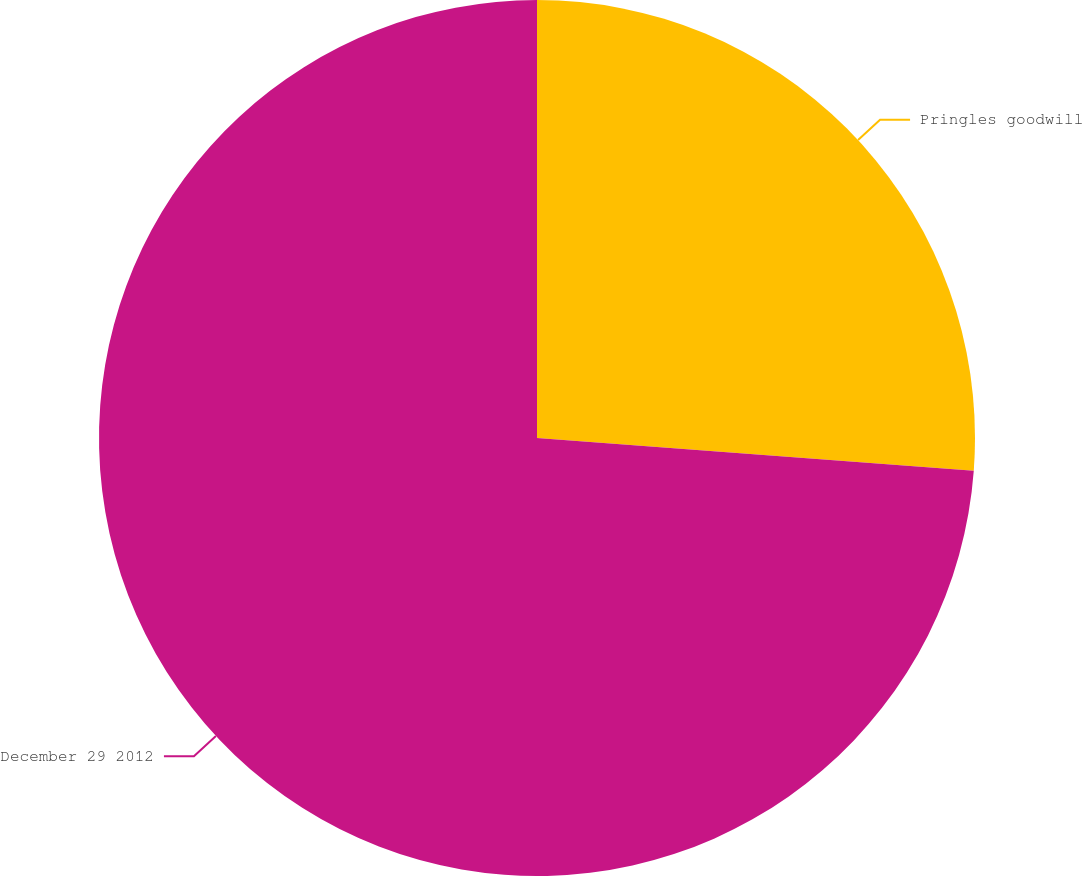<chart> <loc_0><loc_0><loc_500><loc_500><pie_chart><fcel>Pringles goodwill<fcel>December 29 2012<nl><fcel>26.19%<fcel>73.81%<nl></chart> 